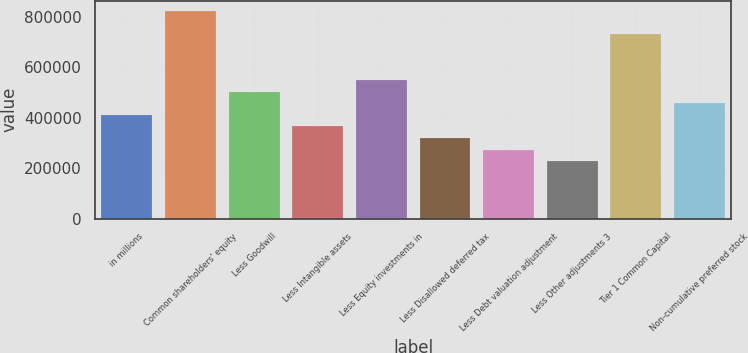Convert chart to OTSL. <chart><loc_0><loc_0><loc_500><loc_500><bar_chart><fcel>in millions<fcel>Common shareholders' equity<fcel>Less Goodwill<fcel>Less Intangible assets<fcel>Less Equity investments in<fcel>Less Disallowed deferred tax<fcel>Less Debt valuation adjustment<fcel>Less Other adjustments 3<fcel>Tier 1 Common Capital<fcel>Non-cumulative preferred stock<nl><fcel>411325<fcel>822643<fcel>502729<fcel>365623<fcel>548431<fcel>319921<fcel>274219<fcel>228517<fcel>731239<fcel>457027<nl></chart> 